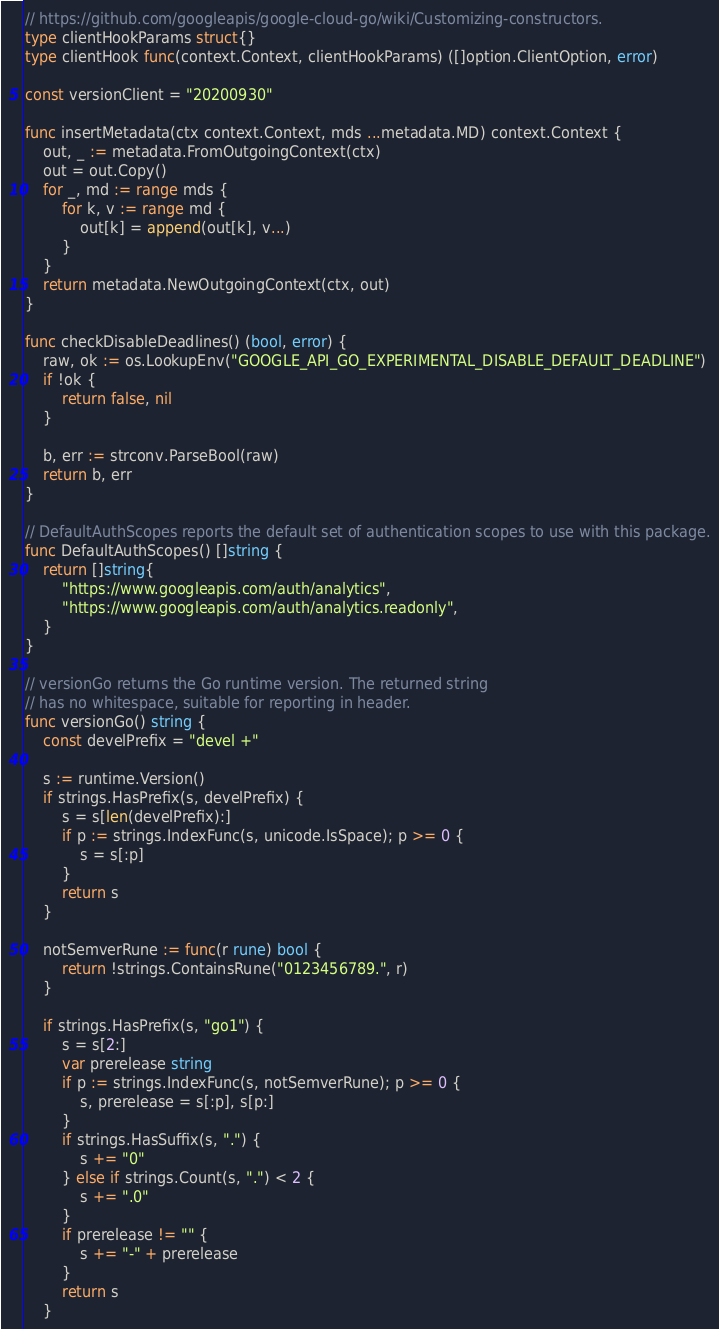Convert code to text. <code><loc_0><loc_0><loc_500><loc_500><_Go_>// https://github.com/googleapis/google-cloud-go/wiki/Customizing-constructors.
type clientHookParams struct{}
type clientHook func(context.Context, clientHookParams) ([]option.ClientOption, error)

const versionClient = "20200930"

func insertMetadata(ctx context.Context, mds ...metadata.MD) context.Context {
	out, _ := metadata.FromOutgoingContext(ctx)
	out = out.Copy()
	for _, md := range mds {
		for k, v := range md {
			out[k] = append(out[k], v...)
		}
	}
	return metadata.NewOutgoingContext(ctx, out)
}

func checkDisableDeadlines() (bool, error) {
	raw, ok := os.LookupEnv("GOOGLE_API_GO_EXPERIMENTAL_DISABLE_DEFAULT_DEADLINE")
	if !ok {
		return false, nil
	}

	b, err := strconv.ParseBool(raw)
	return b, err
}

// DefaultAuthScopes reports the default set of authentication scopes to use with this package.
func DefaultAuthScopes() []string {
	return []string{
		"https://www.googleapis.com/auth/analytics",
		"https://www.googleapis.com/auth/analytics.readonly",
	}
}

// versionGo returns the Go runtime version. The returned string
// has no whitespace, suitable for reporting in header.
func versionGo() string {
	const develPrefix = "devel +"

	s := runtime.Version()
	if strings.HasPrefix(s, develPrefix) {
		s = s[len(develPrefix):]
		if p := strings.IndexFunc(s, unicode.IsSpace); p >= 0 {
			s = s[:p]
		}
		return s
	}

	notSemverRune := func(r rune) bool {
		return !strings.ContainsRune("0123456789.", r)
	}

	if strings.HasPrefix(s, "go1") {
		s = s[2:]
		var prerelease string
		if p := strings.IndexFunc(s, notSemverRune); p >= 0 {
			s, prerelease = s[:p], s[p:]
		}
		if strings.HasSuffix(s, ".") {
			s += "0"
		} else if strings.Count(s, ".") < 2 {
			s += ".0"
		}
		if prerelease != "" {
			s += "-" + prerelease
		}
		return s
	}</code> 